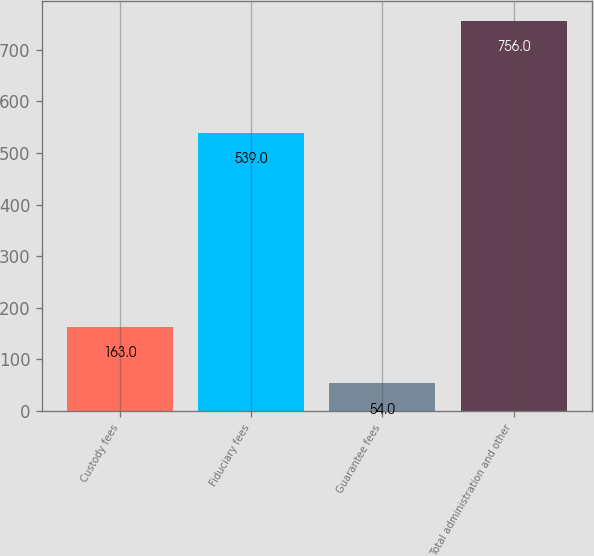Convert chart. <chart><loc_0><loc_0><loc_500><loc_500><bar_chart><fcel>Custody fees<fcel>Fiduciary fees<fcel>Guarantee fees<fcel>Total administration and other<nl><fcel>163<fcel>539<fcel>54<fcel>756<nl></chart> 